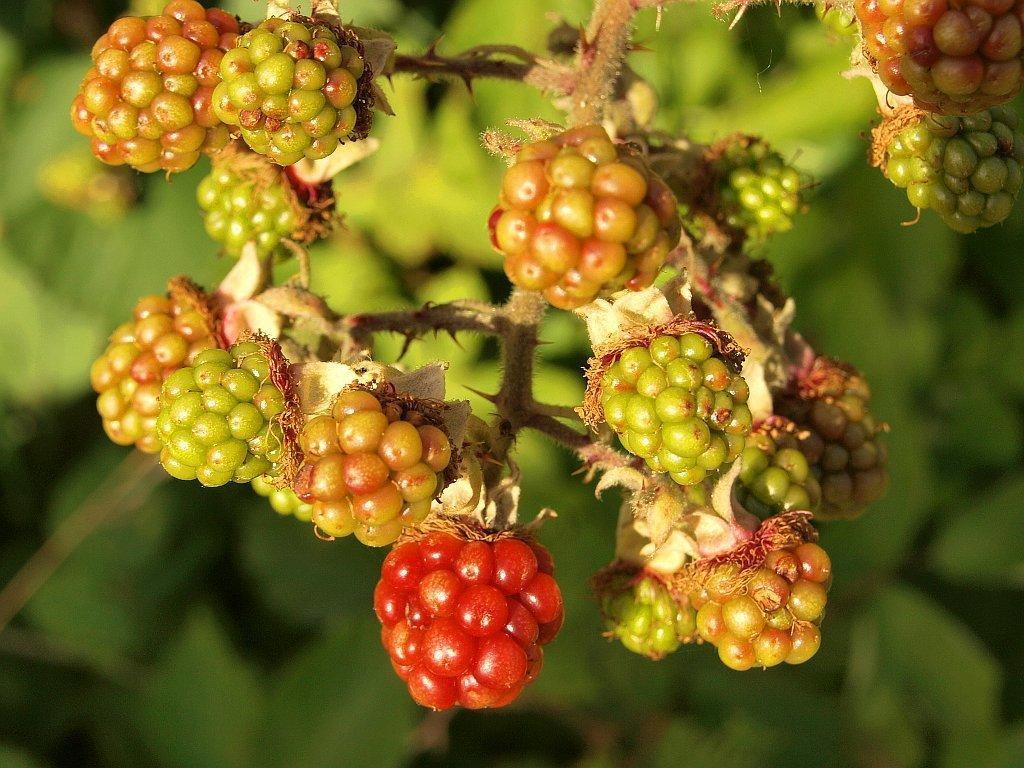What type of fruit is in the foreground of the image? There are cherries in the foreground of the image. What type of vegetation can be seen in the background of the image? There are leaves in the background of the image. How would you describe the overall clarity of the image? The image appears to be blurry. What type of trousers are hanging on the tree in the image? There are no trousers present in the image; it features cherries in the foreground and leaves in the background. What sound does the bell make in the image? There is no bell present in the image. 